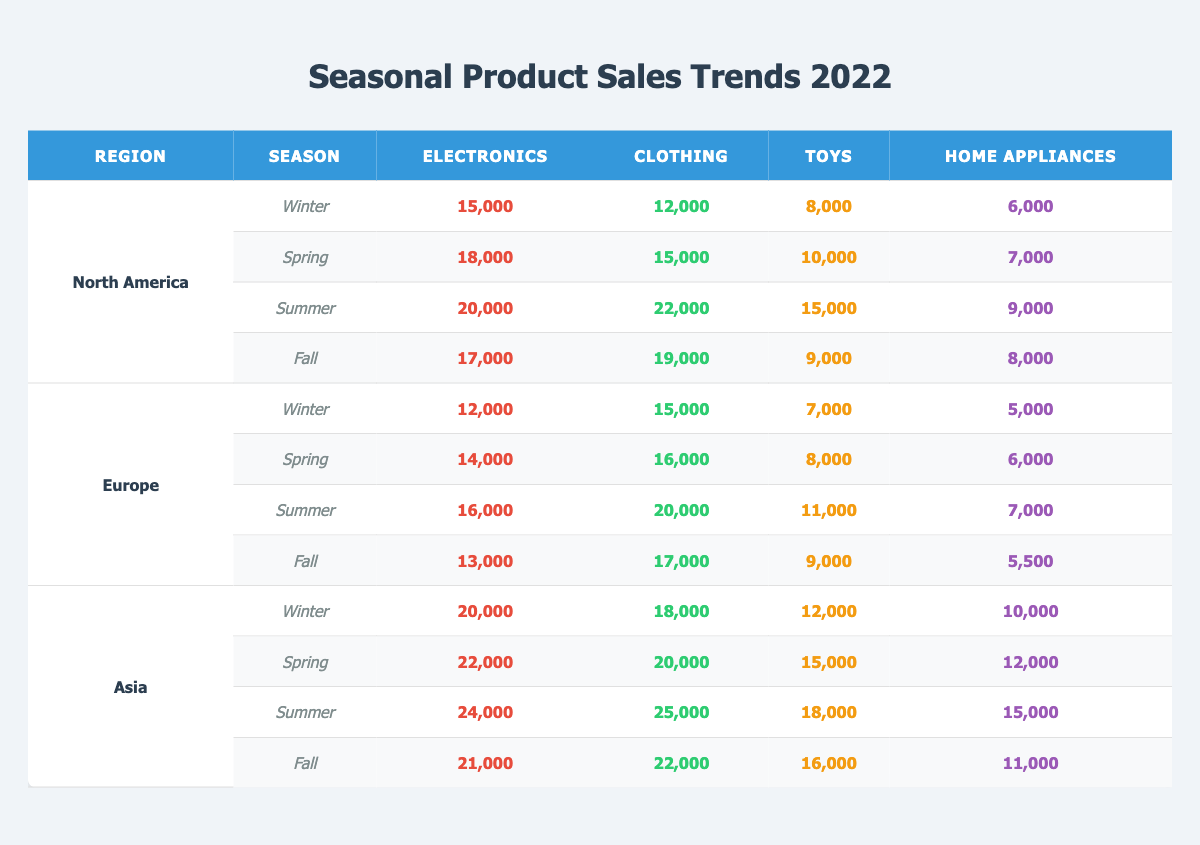What were the total product sales for electronics in North America during Summer? To find this, refer to the North America section for the Summer season. The sales figure for electronics is listed as 20,000.
Answer: 20,000 Which region had the highest clothing sales in Winter? Looking at the Winter sales data, North America has 12,000, Europe has 15,000, and Asia has 18,000. Therefore, Asia has the highest clothing sales in Winter.
Answer: Asia What are the total sales for toys across all regions in Spring? For Spring, the toy sales are as follows: North America has 10,000, Europe has 8,000, and Asia has 15,000. Summing them gives: 10,000 + 8,000 + 15,000 = 33,000.
Answer: 33,000 Is it true that the sales of home appliances in Europe were higher in Summer than in Fall? Check the Fall sales for Europe, which is 5,500, and the Summer sales, which is 7,000. Since 7,000 is greater than 5,500, the statement is true.
Answer: Yes What is the average sales of electronics in Asia for 2022? Add the electronics sales for each season in Asia: Winter 20,000 + Spring 22,000 + Summer 24,000 + Fall 21,000 = 87,000. Then, divide by the number of seasons (4): 87,000 / 4 = 21,750.
Answer: 21,750 How did clothing sales in North America compare to those in Europe during Fall? In Fall, North America sold 19,000 clothing items while Europe sold 17,000. Since 19,000 > 17,000, North America had higher clothing sales than Europe in Fall.
Answer: North America What is the difference in toy sales between Winter and Summer in Asia? Winter toy sales in Asia are 12,000 and Summer sales are 18,000. To find the difference, subtract Winter from Summer: 18,000 - 12,000 = 6,000.
Answer: 6,000 In which season did North America have the lowest home appliance sales? Looking through the North America data, in Winter, the sales were 6,000, in Spring 7,000, in Summer 9,000, and in Fall 8,000. The lowest sales were in Winter at 6,000.
Answer: Winter 